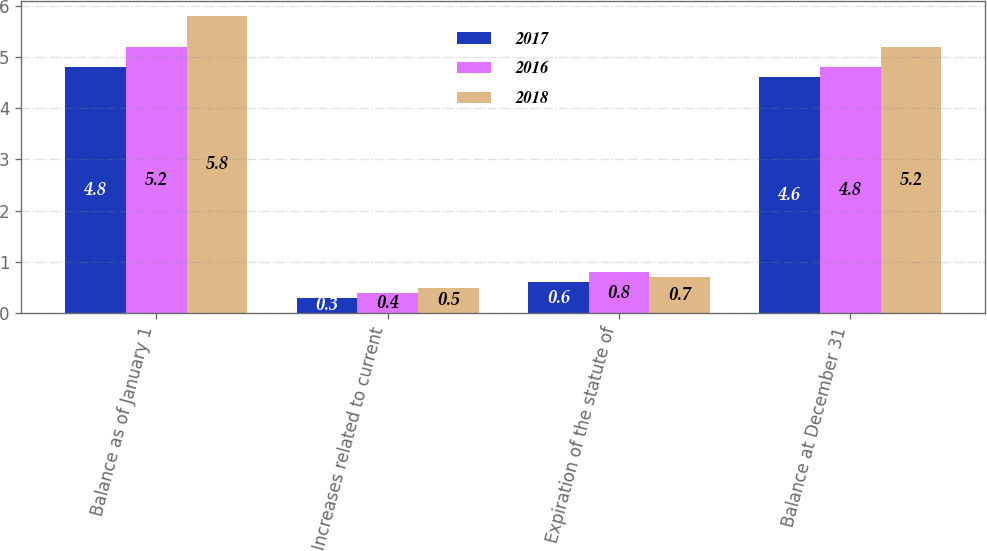Convert chart. <chart><loc_0><loc_0><loc_500><loc_500><stacked_bar_chart><ecel><fcel>Balance as of January 1<fcel>Increases related to current<fcel>Expiration of the statute of<fcel>Balance at December 31<nl><fcel>2017<fcel>4.8<fcel>0.3<fcel>0.6<fcel>4.6<nl><fcel>2016<fcel>5.2<fcel>0.4<fcel>0.8<fcel>4.8<nl><fcel>2018<fcel>5.8<fcel>0.5<fcel>0.7<fcel>5.2<nl></chart> 